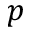<formula> <loc_0><loc_0><loc_500><loc_500>p</formula> 